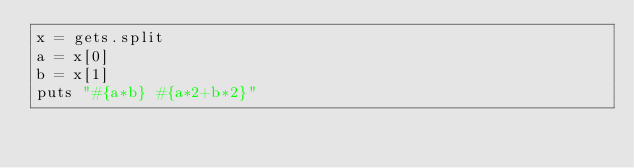<code> <loc_0><loc_0><loc_500><loc_500><_Ruby_>x = gets.split
a = x[0]
b = x[1]
puts "#{a*b} #{a*2+b*2}"</code> 